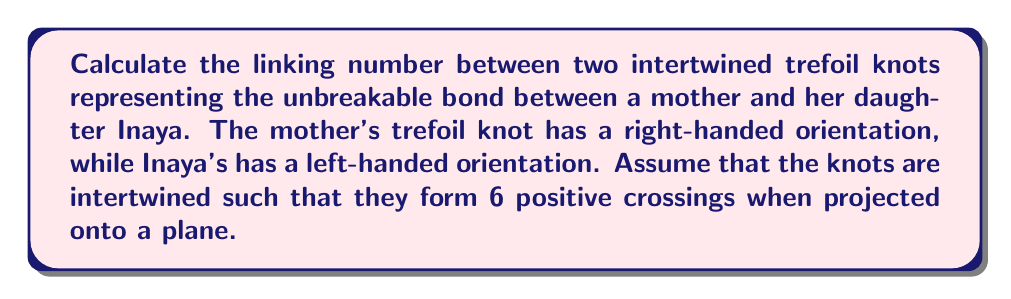Give your solution to this math problem. To calculate the linking number between two intertwined knots, we follow these steps:

1) The linking number is defined as:

   $$\text{Lk}(K_1, K_2) = \frac{1}{2}\sum_{i} \epsilon_i$$

   where $\epsilon_i$ is the sign of each crossing between the two knots.

2) In this case, we're told that there are 6 positive crossings between the mother's and Inaya's knots.

3) Positive crossings contribute +1 to the sum, while negative crossings contribute -1.

4) Since all 6 crossings are positive:

   $$\sum_{i} \epsilon_i = 6$$

5) Applying the formula:

   $$\text{Lk}(K_{\text{mother}}, K_{\text{Inaya}}) = \frac{1}{2} \cdot 6 = 3$$

6) The linking number is always an integer, representing half the algebraic sum of crossings between the two knots.

7) A positive linking number indicates that the knots are linked in a right-handed sense, which aligns with the given information about the mother's right-handed trefoil.

This linking number of 3 symbolizes a strong, intertwined relationship between mother and daughter, reflecting the beauty and depth of their connection, much like the meaning behind Inaya's name.
Answer: 3 